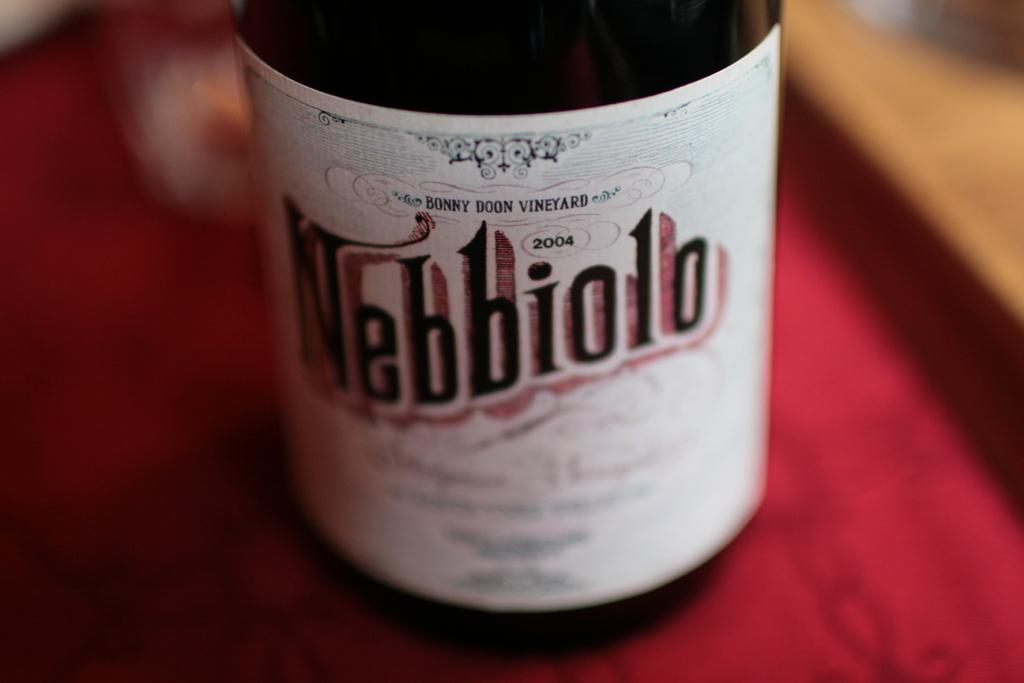<image>
Describe the image concisely. A bottle of nebbiolo sits on a red cloth 